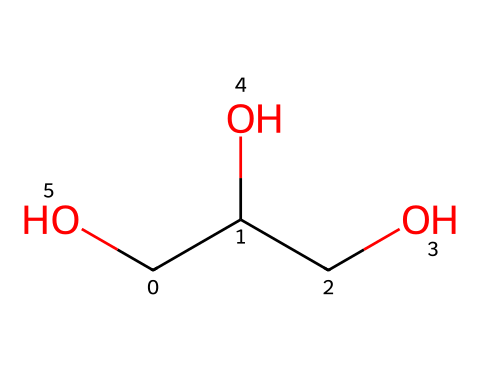How many carbon atoms are in this structure? By analyzing the SMILES representation, we can see there are three 'C' (carbon) symbols present, indicating the presence of three carbon atoms in the molecular structure.
Answer: three What is the total number of oxygen atoms? The SMILES representation includes two 'O' (oxygen) symbols, which indicates that there are two oxygen atoms in the molecular structure.
Answer: two What is the molecular formula for this compound? To derive the molecular formula, we count the respective atoms from the SMILES: 3 Carbons, 8 Hydrogens, and 2 Oxygens, thus giving us C3H8O2.
Answer: C3H8O2 Does this compound have hydroxyl groups? The presence of 'CO' parts in the SMILES indicates hydroxyl (–OH) functional groups, confirming that this compound contains hydroxyl groups which make it an alcohol.
Answer: yes What is the functional group present in this compound? The hydroxyl groups (-OH) in the structure define this compound as an alcohol, which is characterized by these functional groups.
Answer: alcohol Is this compound likely polar or nonpolar? Given the presence of hydroxyl groups and multiple oxygen atoms, which attract water molecules, this compound is likely polar in nature.
Answer: polar What type of solvent can glycerin be classified as? Glycerin, due to its properties and structure, is classified as a polar solvent, ideal for dissolving other polar substances.
Answer: polar solvent 